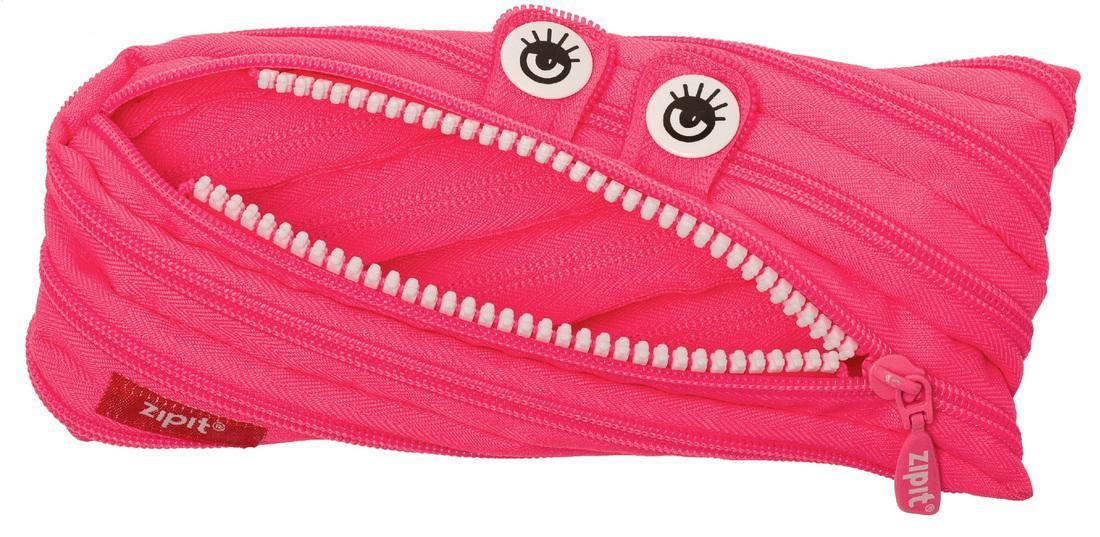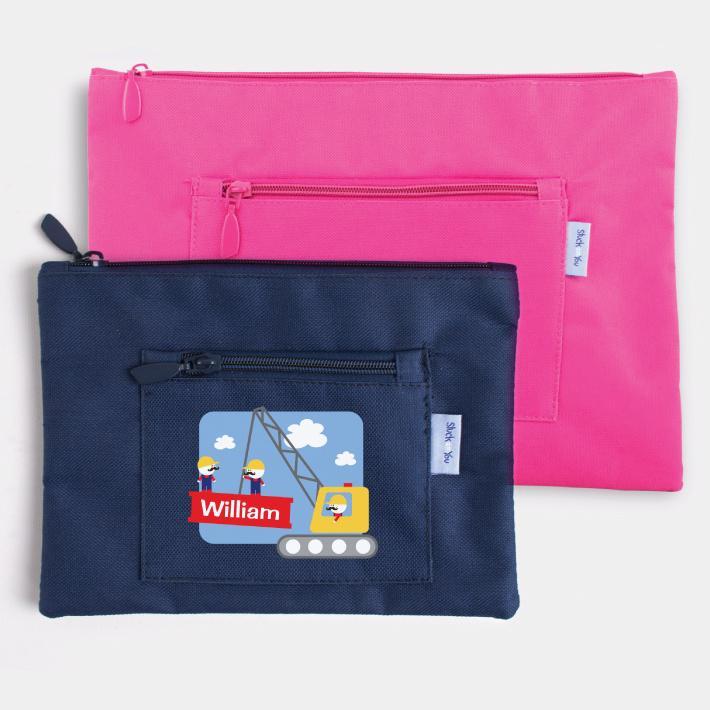The first image is the image on the left, the second image is the image on the right. For the images displayed, is the sentence "Every pouch has eyes." factually correct? Answer yes or no. No. The first image is the image on the left, the second image is the image on the right. Given the left and right images, does the statement "An image shows two closed fabric cases, one pink and one blue." hold true? Answer yes or no. Yes. 